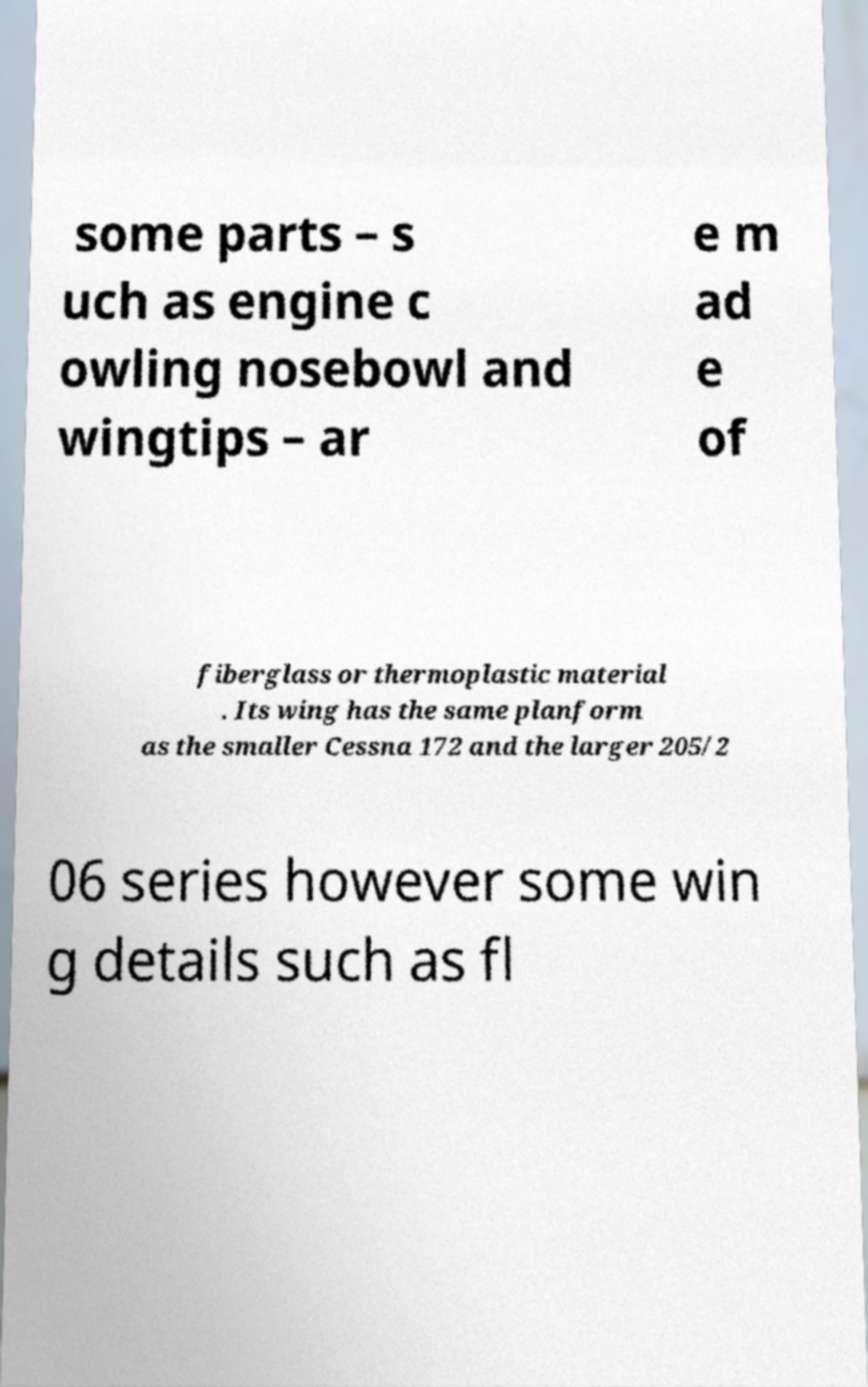What messages or text are displayed in this image? I need them in a readable, typed format. some parts – s uch as engine c owling nosebowl and wingtips – ar e m ad e of fiberglass or thermoplastic material . Its wing has the same planform as the smaller Cessna 172 and the larger 205/2 06 series however some win g details such as fl 